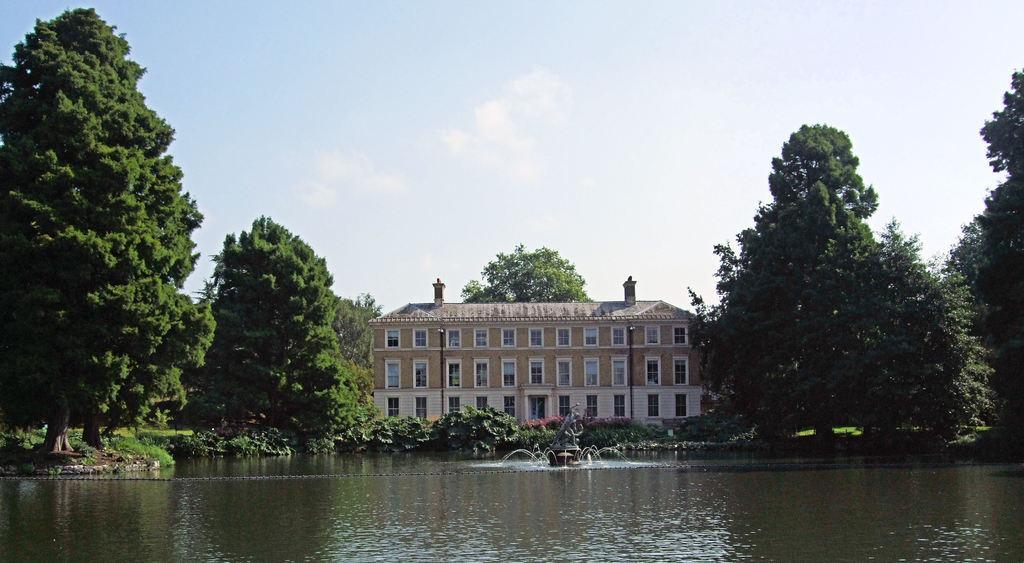How would you summarize this image in a sentence or two? In the picture we can see a lake with water and around it we can see plants and some trees and in the middle of the lake we can see a fountain and behind the plants we can see a house building with many windows and door and behind the building we can see a tree and sky with clouds. 